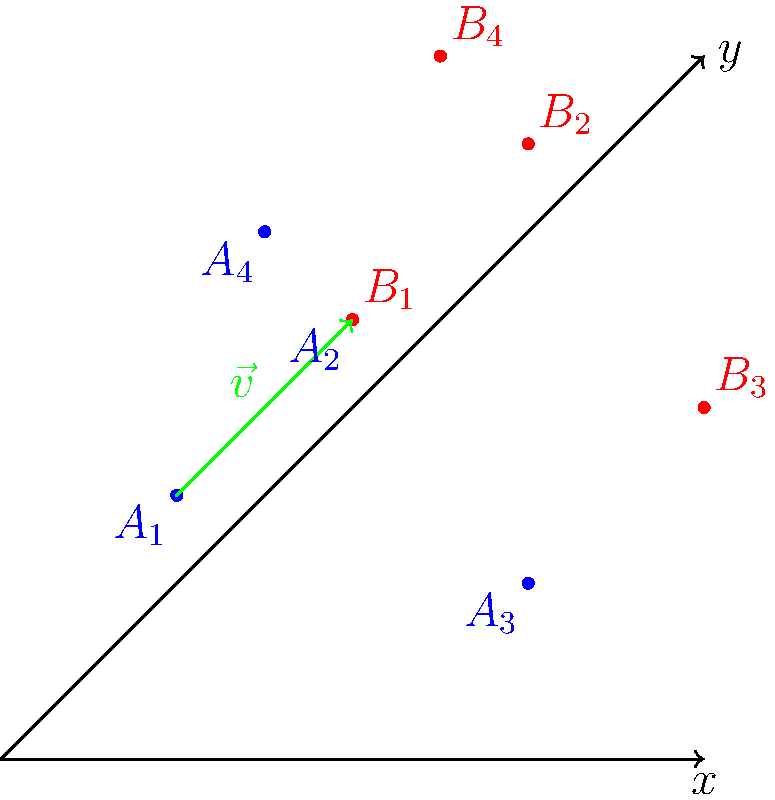In a study of changing voter demographics, four data points representing different voter groups are plotted on a coordinate system (blue points $A_1$, $A_2$, $A_3$, and $A_4$). After a significant policy change, these voter groups have shifted their political positions, represented by the red points $B_1$, $B_2$, $B_3$, and $B_4$. Determine the translation vector $\vec{v}$ that transforms the original voter landscape to the new one, and explain how this transformation can be interpreted in terms of political science and decision theory. To solve this problem, we need to follow these steps:

1. Identify the coordinates of the original points (blue) and the translated points (red):
   $A_1(1,2)$, $A_2(3,4)$, $A_3(5,1)$, $A_4(2,5)$
   $B_1(3,4)$, $B_2(5,6)$, $B_3(7,3)$, $B_4(4,7)$

2. Calculate the translation vector $\vec{v}$ by subtracting any original point from its corresponding translated point:
   $\vec{v} = B_1 - A_1 = (3,4) - (1,2) = (2,2)$

3. Verify that this vector works for all other points:
   $A_2 + (2,2) = (3,4) + (2,2) = (5,6) = B_2$
   $A_3 + (2,2) = (5,1) + (2,2) = (7,3) = B_3$
   $A_4 + (2,2) = (2,5) + (2,2) = (4,7) = B_4$

4. Interpret the transformation in terms of political science and decision theory:
   - The translation vector $\vec{v} = (2,2)$ represents a uniform shift in voter preferences across all groups.
   - The positive x-component (2) could indicate a rightward shift in economic policies.
   - The positive y-component (2) might represent an upward shift in social policies.
   - This uniform shift suggests that the policy change has affected all voter groups similarly, possibly due to a significant event or a persuasive campaign.
   - In decision theory, this could be interpreted as a change in the utility function of voters, where the perceived benefits of certain political positions have increased uniformly across different demographic groups.
   - The magnitude of the shift ($\sqrt{2^2 + 2^2} = 2\sqrt{2}$) indicates the strength of the policy change's impact on voter preferences.
   - Researchers could use this information to analyze the effectiveness of political strategies and predict future voting patterns based on proposed policy changes.
Answer: $\vec{v} = (2,2)$, representing a uniform rightward and upward shift in voter preferences across all demographic groups. 